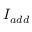<formula> <loc_0><loc_0><loc_500><loc_500>I _ { a d d }</formula> 